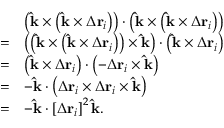<formula> <loc_0><loc_0><loc_500><loc_500>{ \begin{array} { r l } & { \left ( \hat { k } \times \left ( \hat { k } \times \Delta r _ { i } \right ) \right ) \cdot \left ( \hat { k } \times \left ( \hat { k } \times \Delta r _ { i } \right ) \right ) } \\ { = } & { \left ( \left ( \hat { k } \times \left ( \hat { k } \times \Delta r _ { i } \right ) \right ) \times \hat { k } \right ) \cdot \left ( \hat { k } \times \Delta r _ { i } \right ) } \\ { = } & { \left ( \hat { k } \times \Delta r _ { i } \right ) \cdot \left ( - \Delta r _ { i } \times \hat { k } \right ) } \\ { = } & { - \hat { k } \cdot \left ( \Delta r _ { i } \times \Delta r _ { i } \times \hat { k } \right ) } \\ { = } & { - \hat { k } \cdot \left [ \Delta r _ { i } \right ] ^ { 2 } \hat { k } . } \end{array} }</formula> 